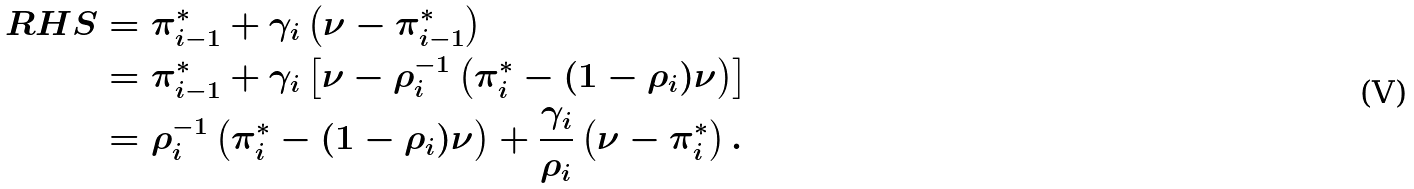<formula> <loc_0><loc_0><loc_500><loc_500>R H S & = \pi ^ { * } _ { i - 1 } + \gamma _ { i } \left ( \nu - \pi ^ { * } _ { i - 1 } \right ) \\ & = \pi ^ { * } _ { i - 1 } + \gamma _ { i } \left [ \nu - \rho ^ { - 1 } _ { i } \left ( \pi ^ { * } _ { i } - ( 1 - \rho _ { i } ) \nu \right ) \right ] \\ & = \rho ^ { - 1 } _ { i } \left ( \pi ^ { * } _ { i } - ( 1 - \rho _ { i } ) \nu \right ) + \frac { \gamma _ { i } } { \rho _ { i } } \left ( \nu - \pi ^ { * } _ { i } \right ) .</formula> 